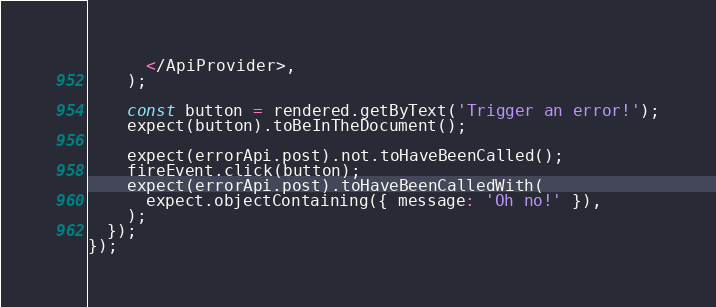Convert code to text. <code><loc_0><loc_0><loc_500><loc_500><_TypeScript_>      </ApiProvider>,
    );

    const button = rendered.getByText('Trigger an error!');
    expect(button).toBeInTheDocument();

    expect(errorApi.post).not.toHaveBeenCalled();
    fireEvent.click(button);
    expect(errorApi.post).toHaveBeenCalledWith(
      expect.objectContaining({ message: 'Oh no!' }),
    );
  });
});
</code> 